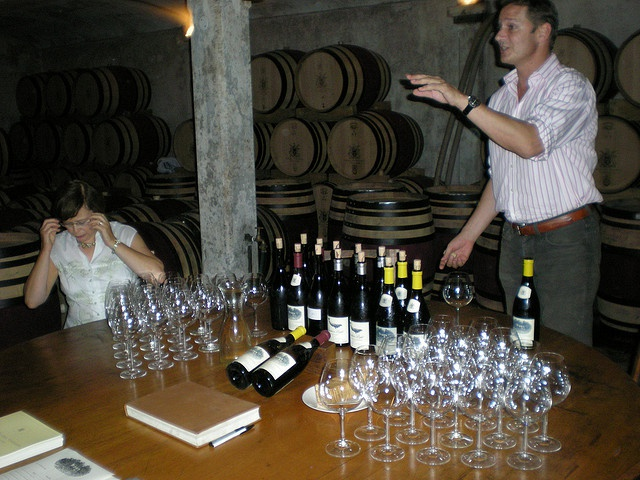Describe the objects in this image and their specific colors. I can see dining table in black, maroon, and gray tones, people in black, darkgray, gray, and lightgray tones, wine glass in black, gray, and darkgray tones, people in black, darkgray, and gray tones, and book in black, brown, ivory, gray, and olive tones in this image. 